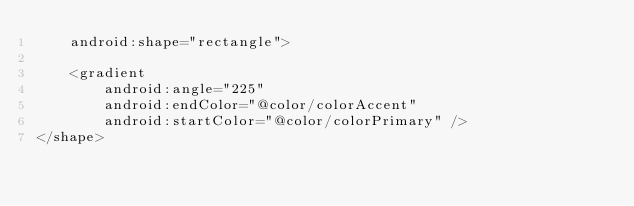Convert code to text. <code><loc_0><loc_0><loc_500><loc_500><_XML_>    android:shape="rectangle">

    <gradient
        android:angle="225"
        android:endColor="@color/colorAccent"
        android:startColor="@color/colorPrimary" />
</shape></code> 